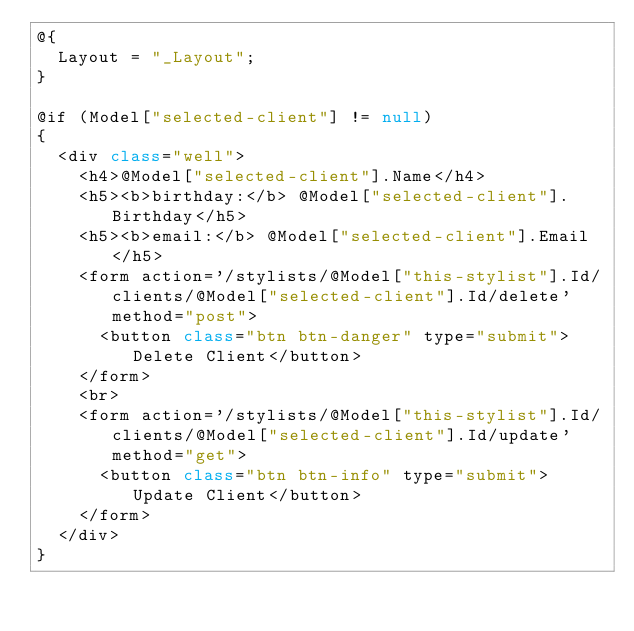<code> <loc_0><loc_0><loc_500><loc_500><_C#_>@{
  Layout = "_Layout";
}

@if (Model["selected-client"] != null)
{
  <div class="well">
    <h4>@Model["selected-client"].Name</h4>
    <h5><b>birthday:</b> @Model["selected-client"].Birthday</h5>
    <h5><b>email:</b> @Model["selected-client"].Email</h5>
    <form action='/stylists/@Model["this-stylist"].Id/clients/@Model["selected-client"].Id/delete' method="post">
      <button class="btn btn-danger" type="submit">Delete Client</button>
    </form>
    <br>
    <form action='/stylists/@Model["this-stylist"].Id/clients/@Model["selected-client"].Id/update' method="get">
      <button class="btn btn-info" type="submit">Update Client</button>
    </form>
  </div>
}
</code> 